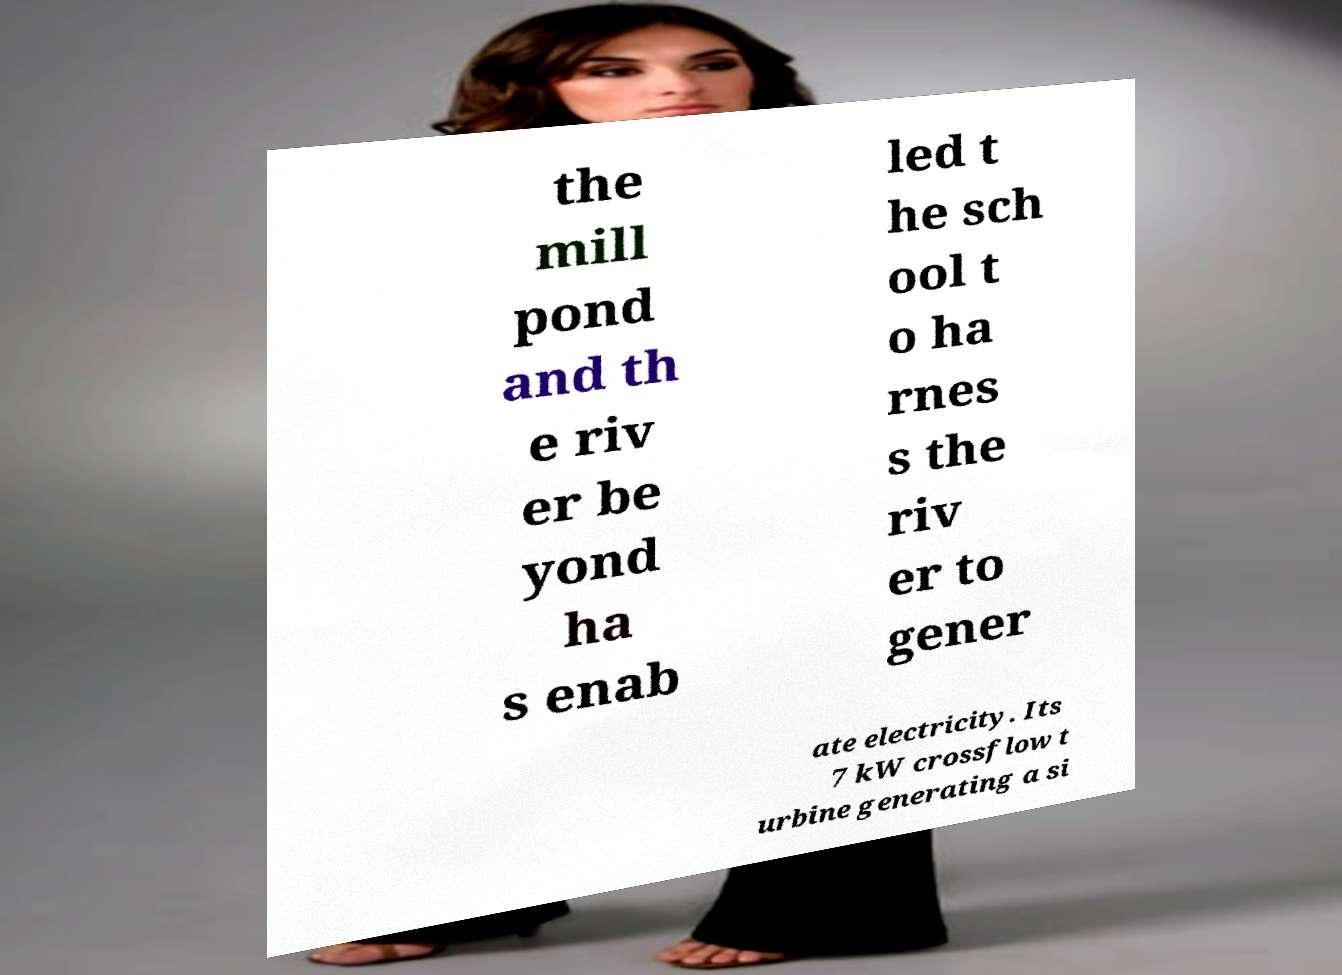What messages or text are displayed in this image? I need them in a readable, typed format. the mill pond and th e riv er be yond ha s enab led t he sch ool t o ha rnes s the riv er to gener ate electricity. Its 7 kW crossflow t urbine generating a si 